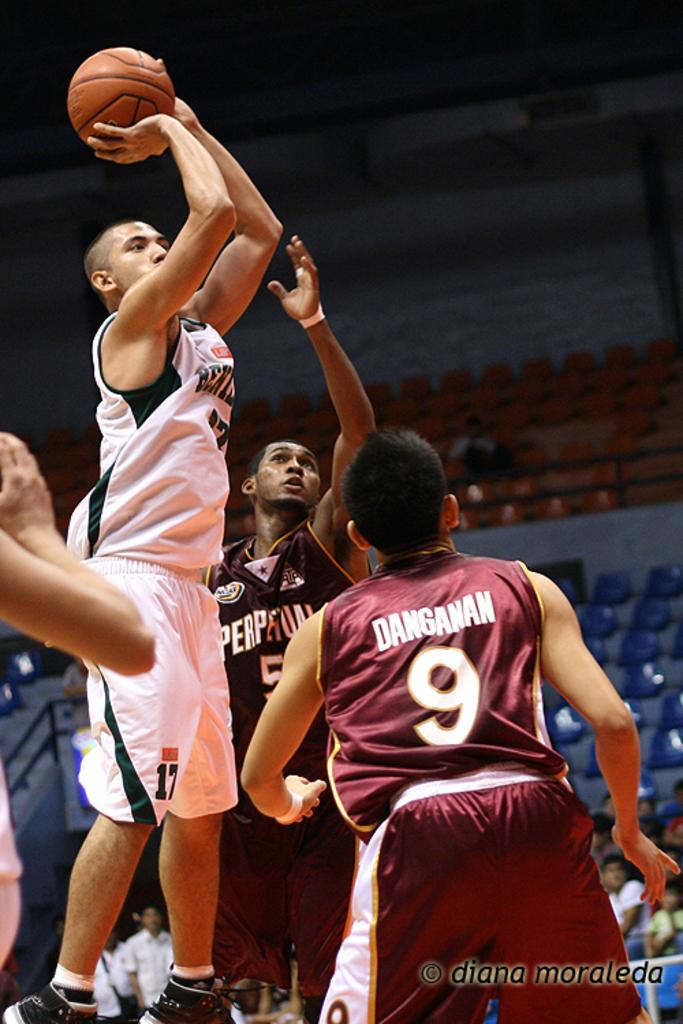<image>
Provide a brief description of the given image. People playing basketball, including Danganan wearing number 9. 